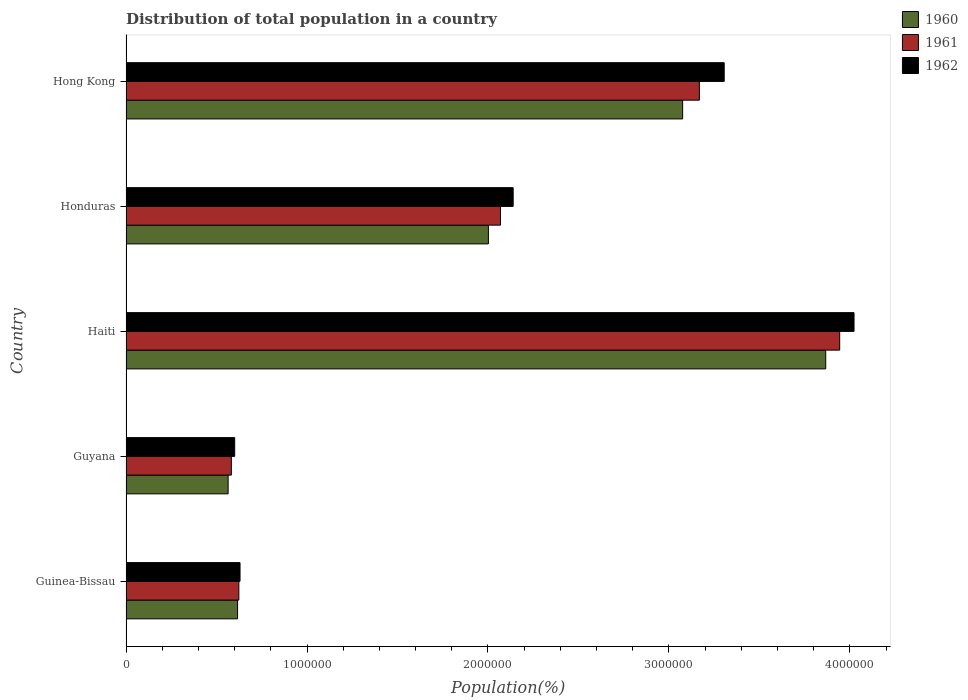How many different coloured bars are there?
Offer a terse response. 3. How many groups of bars are there?
Your response must be concise. 5. Are the number of bars per tick equal to the number of legend labels?
Your answer should be very brief. Yes. What is the label of the 3rd group of bars from the top?
Ensure brevity in your answer.  Haiti. What is the population of in 1960 in Guinea-Bissau?
Ensure brevity in your answer.  6.16e+05. Across all countries, what is the maximum population of in 1961?
Your answer should be very brief. 3.94e+06. Across all countries, what is the minimum population of in 1961?
Your answer should be very brief. 5.82e+05. In which country was the population of in 1960 maximum?
Give a very brief answer. Haiti. In which country was the population of in 1960 minimum?
Your response must be concise. Guyana. What is the total population of in 1962 in the graph?
Your response must be concise. 1.07e+07. What is the difference between the population of in 1962 in Guyana and that in Honduras?
Provide a succinct answer. -1.54e+06. What is the difference between the population of in 1962 in Guyana and the population of in 1960 in Hong Kong?
Make the answer very short. -2.48e+06. What is the average population of in 1960 per country?
Give a very brief answer. 2.02e+06. What is the difference between the population of in 1961 and population of in 1962 in Honduras?
Your response must be concise. -7.01e+04. What is the ratio of the population of in 1962 in Guyana to that in Hong Kong?
Ensure brevity in your answer.  0.18. Is the population of in 1962 in Guinea-Bissau less than that in Hong Kong?
Offer a terse response. Yes. What is the difference between the highest and the second highest population of in 1961?
Give a very brief answer. 7.75e+05. What is the difference between the highest and the lowest population of in 1961?
Keep it short and to the point. 3.36e+06. What is the difference between two consecutive major ticks on the X-axis?
Ensure brevity in your answer.  1.00e+06. Does the graph contain any zero values?
Give a very brief answer. No. Does the graph contain grids?
Provide a short and direct response. No. Where does the legend appear in the graph?
Keep it short and to the point. Top right. How many legend labels are there?
Keep it short and to the point. 3. What is the title of the graph?
Keep it short and to the point. Distribution of total population in a country. What is the label or title of the X-axis?
Ensure brevity in your answer.  Population(%). What is the label or title of the Y-axis?
Your answer should be very brief. Country. What is the Population(%) of 1960 in Guinea-Bissau?
Give a very brief answer. 6.16e+05. What is the Population(%) of 1961 in Guinea-Bissau?
Ensure brevity in your answer.  6.23e+05. What is the Population(%) in 1962 in Guinea-Bissau?
Offer a terse response. 6.30e+05. What is the Population(%) in 1960 in Guyana?
Your answer should be very brief. 5.64e+05. What is the Population(%) in 1961 in Guyana?
Provide a short and direct response. 5.82e+05. What is the Population(%) of 1962 in Guyana?
Offer a terse response. 6.01e+05. What is the Population(%) of 1960 in Haiti?
Ensure brevity in your answer.  3.87e+06. What is the Population(%) in 1961 in Haiti?
Keep it short and to the point. 3.94e+06. What is the Population(%) of 1962 in Haiti?
Provide a short and direct response. 4.02e+06. What is the Population(%) of 1960 in Honduras?
Keep it short and to the point. 2.00e+06. What is the Population(%) of 1961 in Honduras?
Your answer should be compact. 2.07e+06. What is the Population(%) in 1962 in Honduras?
Offer a terse response. 2.14e+06. What is the Population(%) of 1960 in Hong Kong?
Your answer should be very brief. 3.08e+06. What is the Population(%) of 1961 in Hong Kong?
Your answer should be compact. 3.17e+06. What is the Population(%) of 1962 in Hong Kong?
Offer a terse response. 3.31e+06. Across all countries, what is the maximum Population(%) in 1960?
Your response must be concise. 3.87e+06. Across all countries, what is the maximum Population(%) in 1961?
Offer a very short reply. 3.94e+06. Across all countries, what is the maximum Population(%) of 1962?
Your answer should be compact. 4.02e+06. Across all countries, what is the minimum Population(%) in 1960?
Your answer should be very brief. 5.64e+05. Across all countries, what is the minimum Population(%) in 1961?
Your answer should be very brief. 5.82e+05. Across all countries, what is the minimum Population(%) of 1962?
Your answer should be very brief. 6.01e+05. What is the total Population(%) of 1960 in the graph?
Your answer should be very brief. 1.01e+07. What is the total Population(%) in 1961 in the graph?
Make the answer very short. 1.04e+07. What is the total Population(%) of 1962 in the graph?
Your answer should be very brief. 1.07e+07. What is the difference between the Population(%) in 1960 in Guinea-Bissau and that in Guyana?
Provide a short and direct response. 5.22e+04. What is the difference between the Population(%) in 1961 in Guinea-Bissau and that in Guyana?
Offer a very short reply. 4.14e+04. What is the difference between the Population(%) in 1962 in Guinea-Bissau and that in Guyana?
Your answer should be very brief. 2.94e+04. What is the difference between the Population(%) in 1960 in Guinea-Bissau and that in Haiti?
Offer a very short reply. -3.25e+06. What is the difference between the Population(%) in 1961 in Guinea-Bissau and that in Haiti?
Offer a very short reply. -3.32e+06. What is the difference between the Population(%) in 1962 in Guinea-Bissau and that in Haiti?
Offer a very short reply. -3.39e+06. What is the difference between the Population(%) of 1960 in Guinea-Bissau and that in Honduras?
Make the answer very short. -1.39e+06. What is the difference between the Population(%) of 1961 in Guinea-Bissau and that in Honduras?
Ensure brevity in your answer.  -1.45e+06. What is the difference between the Population(%) of 1962 in Guinea-Bissau and that in Honduras?
Offer a terse response. -1.51e+06. What is the difference between the Population(%) of 1960 in Guinea-Bissau and that in Hong Kong?
Your response must be concise. -2.46e+06. What is the difference between the Population(%) in 1961 in Guinea-Bissau and that in Hong Kong?
Offer a terse response. -2.54e+06. What is the difference between the Population(%) of 1962 in Guinea-Bissau and that in Hong Kong?
Offer a very short reply. -2.68e+06. What is the difference between the Population(%) in 1960 in Guyana and that in Haiti?
Ensure brevity in your answer.  -3.30e+06. What is the difference between the Population(%) in 1961 in Guyana and that in Haiti?
Your answer should be compact. -3.36e+06. What is the difference between the Population(%) in 1962 in Guyana and that in Haiti?
Your answer should be compact. -3.42e+06. What is the difference between the Population(%) of 1960 in Guyana and that in Honduras?
Offer a terse response. -1.44e+06. What is the difference between the Population(%) of 1961 in Guyana and that in Honduras?
Keep it short and to the point. -1.49e+06. What is the difference between the Population(%) in 1962 in Guyana and that in Honduras?
Offer a very short reply. -1.54e+06. What is the difference between the Population(%) in 1960 in Guyana and that in Hong Kong?
Offer a very short reply. -2.51e+06. What is the difference between the Population(%) in 1961 in Guyana and that in Hong Kong?
Your response must be concise. -2.59e+06. What is the difference between the Population(%) in 1962 in Guyana and that in Hong Kong?
Offer a terse response. -2.70e+06. What is the difference between the Population(%) in 1960 in Haiti and that in Honduras?
Keep it short and to the point. 1.86e+06. What is the difference between the Population(%) of 1961 in Haiti and that in Honduras?
Offer a terse response. 1.87e+06. What is the difference between the Population(%) in 1962 in Haiti and that in Honduras?
Your answer should be very brief. 1.88e+06. What is the difference between the Population(%) in 1960 in Haiti and that in Hong Kong?
Your answer should be very brief. 7.91e+05. What is the difference between the Population(%) of 1961 in Haiti and that in Hong Kong?
Ensure brevity in your answer.  7.75e+05. What is the difference between the Population(%) in 1962 in Haiti and that in Hong Kong?
Keep it short and to the point. 7.17e+05. What is the difference between the Population(%) in 1960 in Honduras and that in Hong Kong?
Your response must be concise. -1.07e+06. What is the difference between the Population(%) of 1961 in Honduras and that in Hong Kong?
Make the answer very short. -1.10e+06. What is the difference between the Population(%) of 1962 in Honduras and that in Hong Kong?
Keep it short and to the point. -1.17e+06. What is the difference between the Population(%) of 1960 in Guinea-Bissau and the Population(%) of 1961 in Guyana?
Your response must be concise. 3.44e+04. What is the difference between the Population(%) in 1960 in Guinea-Bissau and the Population(%) in 1962 in Guyana?
Offer a very short reply. 1.58e+04. What is the difference between the Population(%) of 1961 in Guinea-Bissau and the Population(%) of 1962 in Guyana?
Ensure brevity in your answer.  2.29e+04. What is the difference between the Population(%) of 1960 in Guinea-Bissau and the Population(%) of 1961 in Haiti?
Ensure brevity in your answer.  -3.33e+06. What is the difference between the Population(%) of 1960 in Guinea-Bissau and the Population(%) of 1962 in Haiti?
Offer a very short reply. -3.41e+06. What is the difference between the Population(%) of 1961 in Guinea-Bissau and the Population(%) of 1962 in Haiti?
Your answer should be very brief. -3.40e+06. What is the difference between the Population(%) of 1960 in Guinea-Bissau and the Population(%) of 1961 in Honduras?
Make the answer very short. -1.45e+06. What is the difference between the Population(%) in 1960 in Guinea-Bissau and the Population(%) in 1962 in Honduras?
Give a very brief answer. -1.52e+06. What is the difference between the Population(%) in 1961 in Guinea-Bissau and the Population(%) in 1962 in Honduras?
Provide a succinct answer. -1.52e+06. What is the difference between the Population(%) in 1960 in Guinea-Bissau and the Population(%) in 1961 in Hong Kong?
Offer a very short reply. -2.55e+06. What is the difference between the Population(%) in 1960 in Guinea-Bissau and the Population(%) in 1962 in Hong Kong?
Provide a succinct answer. -2.69e+06. What is the difference between the Population(%) in 1961 in Guinea-Bissau and the Population(%) in 1962 in Hong Kong?
Make the answer very short. -2.68e+06. What is the difference between the Population(%) of 1960 in Guyana and the Population(%) of 1961 in Haiti?
Provide a short and direct response. -3.38e+06. What is the difference between the Population(%) in 1960 in Guyana and the Population(%) in 1962 in Haiti?
Keep it short and to the point. -3.46e+06. What is the difference between the Population(%) in 1961 in Guyana and the Population(%) in 1962 in Haiti?
Provide a short and direct response. -3.44e+06. What is the difference between the Population(%) of 1960 in Guyana and the Population(%) of 1961 in Honduras?
Make the answer very short. -1.50e+06. What is the difference between the Population(%) of 1960 in Guyana and the Population(%) of 1962 in Honduras?
Offer a very short reply. -1.57e+06. What is the difference between the Population(%) in 1961 in Guyana and the Population(%) in 1962 in Honduras?
Make the answer very short. -1.56e+06. What is the difference between the Population(%) of 1960 in Guyana and the Population(%) of 1961 in Hong Kong?
Your response must be concise. -2.60e+06. What is the difference between the Population(%) of 1960 in Guyana and the Population(%) of 1962 in Hong Kong?
Make the answer very short. -2.74e+06. What is the difference between the Population(%) of 1961 in Guyana and the Population(%) of 1962 in Hong Kong?
Offer a very short reply. -2.72e+06. What is the difference between the Population(%) of 1960 in Haiti and the Population(%) of 1961 in Honduras?
Give a very brief answer. 1.80e+06. What is the difference between the Population(%) of 1960 in Haiti and the Population(%) of 1962 in Honduras?
Ensure brevity in your answer.  1.73e+06. What is the difference between the Population(%) in 1961 in Haiti and the Population(%) in 1962 in Honduras?
Your response must be concise. 1.80e+06. What is the difference between the Population(%) of 1960 in Haiti and the Population(%) of 1961 in Hong Kong?
Offer a terse response. 6.98e+05. What is the difference between the Population(%) of 1960 in Haiti and the Population(%) of 1962 in Hong Kong?
Make the answer very short. 5.61e+05. What is the difference between the Population(%) of 1961 in Haiti and the Population(%) of 1962 in Hong Kong?
Provide a succinct answer. 6.38e+05. What is the difference between the Population(%) of 1960 in Honduras and the Population(%) of 1961 in Hong Kong?
Your response must be concise. -1.17e+06. What is the difference between the Population(%) in 1960 in Honduras and the Population(%) in 1962 in Hong Kong?
Your answer should be compact. -1.30e+06. What is the difference between the Population(%) of 1961 in Honduras and the Population(%) of 1962 in Hong Kong?
Offer a very short reply. -1.24e+06. What is the average Population(%) of 1960 per country?
Give a very brief answer. 2.02e+06. What is the average Population(%) of 1961 per country?
Ensure brevity in your answer.  2.08e+06. What is the average Population(%) in 1962 per country?
Make the answer very short. 2.14e+06. What is the difference between the Population(%) of 1960 and Population(%) of 1961 in Guinea-Bissau?
Make the answer very short. -7006. What is the difference between the Population(%) of 1960 and Population(%) of 1962 in Guinea-Bissau?
Offer a terse response. -1.36e+04. What is the difference between the Population(%) in 1961 and Population(%) in 1962 in Guinea-Bissau?
Keep it short and to the point. -6560. What is the difference between the Population(%) of 1960 and Population(%) of 1961 in Guyana?
Your answer should be compact. -1.78e+04. What is the difference between the Population(%) of 1960 and Population(%) of 1962 in Guyana?
Offer a very short reply. -3.63e+04. What is the difference between the Population(%) in 1961 and Population(%) in 1962 in Guyana?
Ensure brevity in your answer.  -1.85e+04. What is the difference between the Population(%) of 1960 and Population(%) of 1961 in Haiti?
Provide a short and direct response. -7.72e+04. What is the difference between the Population(%) in 1960 and Population(%) in 1962 in Haiti?
Provide a short and direct response. -1.56e+05. What is the difference between the Population(%) of 1961 and Population(%) of 1962 in Haiti?
Your answer should be very brief. -7.92e+04. What is the difference between the Population(%) of 1960 and Population(%) of 1961 in Honduras?
Your answer should be compact. -6.68e+04. What is the difference between the Population(%) in 1960 and Population(%) in 1962 in Honduras?
Offer a terse response. -1.37e+05. What is the difference between the Population(%) of 1961 and Population(%) of 1962 in Honduras?
Keep it short and to the point. -7.01e+04. What is the difference between the Population(%) in 1960 and Population(%) in 1961 in Hong Kong?
Keep it short and to the point. -9.25e+04. What is the difference between the Population(%) in 1960 and Population(%) in 1962 in Hong Kong?
Provide a short and direct response. -2.30e+05. What is the difference between the Population(%) of 1961 and Population(%) of 1962 in Hong Kong?
Offer a very short reply. -1.37e+05. What is the ratio of the Population(%) in 1960 in Guinea-Bissau to that in Guyana?
Give a very brief answer. 1.09. What is the ratio of the Population(%) in 1961 in Guinea-Bissau to that in Guyana?
Provide a short and direct response. 1.07. What is the ratio of the Population(%) in 1962 in Guinea-Bissau to that in Guyana?
Your response must be concise. 1.05. What is the ratio of the Population(%) in 1960 in Guinea-Bissau to that in Haiti?
Make the answer very short. 0.16. What is the ratio of the Population(%) in 1961 in Guinea-Bissau to that in Haiti?
Give a very brief answer. 0.16. What is the ratio of the Population(%) of 1962 in Guinea-Bissau to that in Haiti?
Ensure brevity in your answer.  0.16. What is the ratio of the Population(%) of 1960 in Guinea-Bissau to that in Honduras?
Provide a succinct answer. 0.31. What is the ratio of the Population(%) of 1961 in Guinea-Bissau to that in Honduras?
Make the answer very short. 0.3. What is the ratio of the Population(%) in 1962 in Guinea-Bissau to that in Honduras?
Your response must be concise. 0.29. What is the ratio of the Population(%) of 1960 in Guinea-Bissau to that in Hong Kong?
Ensure brevity in your answer.  0.2. What is the ratio of the Population(%) of 1961 in Guinea-Bissau to that in Hong Kong?
Your response must be concise. 0.2. What is the ratio of the Population(%) in 1962 in Guinea-Bissau to that in Hong Kong?
Make the answer very short. 0.19. What is the ratio of the Population(%) in 1960 in Guyana to that in Haiti?
Your answer should be very brief. 0.15. What is the ratio of the Population(%) of 1961 in Guyana to that in Haiti?
Your answer should be very brief. 0.15. What is the ratio of the Population(%) of 1962 in Guyana to that in Haiti?
Keep it short and to the point. 0.15. What is the ratio of the Population(%) of 1960 in Guyana to that in Honduras?
Keep it short and to the point. 0.28. What is the ratio of the Population(%) in 1961 in Guyana to that in Honduras?
Offer a very short reply. 0.28. What is the ratio of the Population(%) in 1962 in Guyana to that in Honduras?
Offer a terse response. 0.28. What is the ratio of the Population(%) of 1960 in Guyana to that in Hong Kong?
Your answer should be very brief. 0.18. What is the ratio of the Population(%) of 1961 in Guyana to that in Hong Kong?
Provide a succinct answer. 0.18. What is the ratio of the Population(%) of 1962 in Guyana to that in Hong Kong?
Offer a very short reply. 0.18. What is the ratio of the Population(%) of 1960 in Haiti to that in Honduras?
Your response must be concise. 1.93. What is the ratio of the Population(%) in 1961 in Haiti to that in Honduras?
Offer a very short reply. 1.91. What is the ratio of the Population(%) in 1962 in Haiti to that in Honduras?
Ensure brevity in your answer.  1.88. What is the ratio of the Population(%) of 1960 in Haiti to that in Hong Kong?
Your response must be concise. 1.26. What is the ratio of the Population(%) in 1961 in Haiti to that in Hong Kong?
Keep it short and to the point. 1.24. What is the ratio of the Population(%) in 1962 in Haiti to that in Hong Kong?
Your answer should be compact. 1.22. What is the ratio of the Population(%) of 1960 in Honduras to that in Hong Kong?
Make the answer very short. 0.65. What is the ratio of the Population(%) in 1961 in Honduras to that in Hong Kong?
Provide a short and direct response. 0.65. What is the ratio of the Population(%) of 1962 in Honduras to that in Hong Kong?
Provide a short and direct response. 0.65. What is the difference between the highest and the second highest Population(%) in 1960?
Give a very brief answer. 7.91e+05. What is the difference between the highest and the second highest Population(%) of 1961?
Offer a very short reply. 7.75e+05. What is the difference between the highest and the second highest Population(%) in 1962?
Offer a very short reply. 7.17e+05. What is the difference between the highest and the lowest Population(%) in 1960?
Make the answer very short. 3.30e+06. What is the difference between the highest and the lowest Population(%) of 1961?
Give a very brief answer. 3.36e+06. What is the difference between the highest and the lowest Population(%) in 1962?
Make the answer very short. 3.42e+06. 